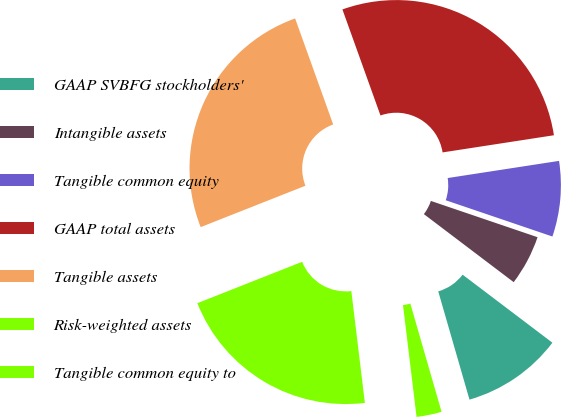Convert chart to OTSL. <chart><loc_0><loc_0><loc_500><loc_500><pie_chart><fcel>GAAP SVBFG stockholders'<fcel>Intangible assets<fcel>Tangible common equity<fcel>GAAP total assets<fcel>Tangible assets<fcel>Risk-weighted assets<fcel>Tangible common equity to<nl><fcel>10.21%<fcel>5.1%<fcel>7.65%<fcel>28.05%<fcel>25.5%<fcel>20.93%<fcel>2.55%<nl></chart> 